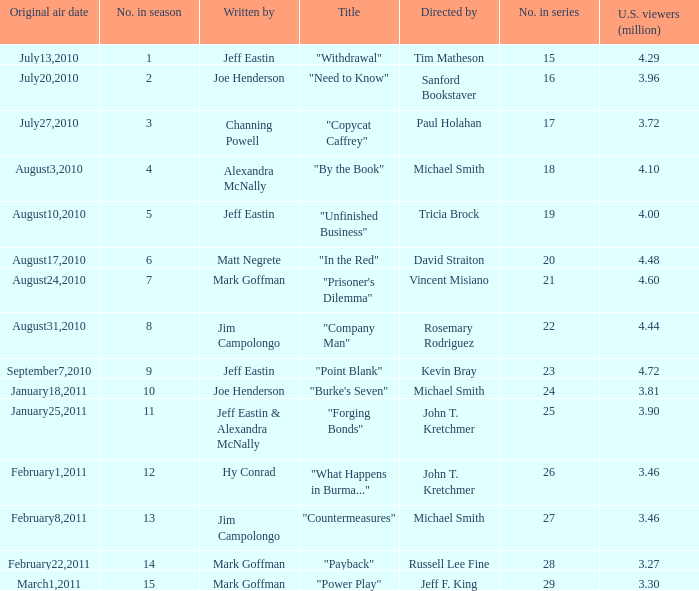How many episodes in the season had 3.81 million US viewers? 1.0. 